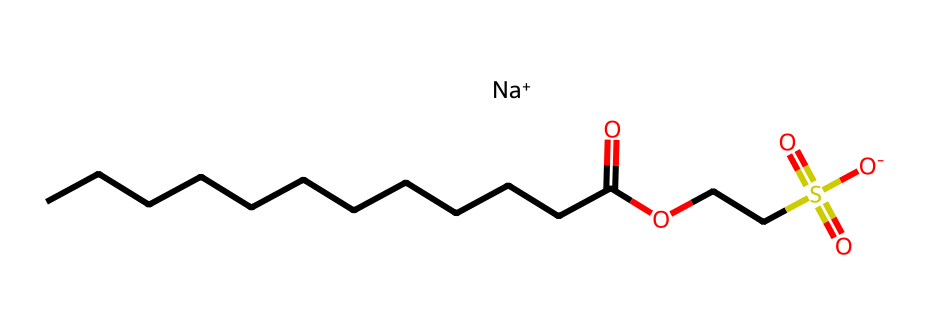What is the main functional group present in this chemical? The chemical has a carboxylic acid functional group, indicated by the -COOH structure (where a carbon atom is double-bonded to one oxygen atom and single-bonded to a hydroxyl group). The presence of the -COO- also shows it is an ester, but the carboxylic part is most prominent.
Answer: carboxylic acid How many carbon atoms are in the longest carbon chain? The longest carbon chain is represented by the series of connected 'C's in the SMILES, which shows there are 12 carbon atoms before the carboxylic acid functional group.
Answer: twelve What is the role of the sodium ion in this chemical structure? The sodium ion is present to balance the negative charge of the sulfonate group (represented as -S(=O)(=O)[O-]), which facilitates the detergent's solubility in water.
Answer: solubility What type of substance is this chemical classified as? The chemical is classified as an anionic surfactant due to the presence of the negatively charged sulfonate group, which is characteristic of detergents that help in emulsifying dirt and oils.
Answer: anionic surfactant What characteristic of this detergent makes it suitable for sensitive skin? The "pH-neutral" labeling indicates that it is designed to not irritate the skin's natural balance, which is critical for sensitive skin formulations. The absence of harsh ingredients further supports this characteristic.
Answer: pH-neutral 